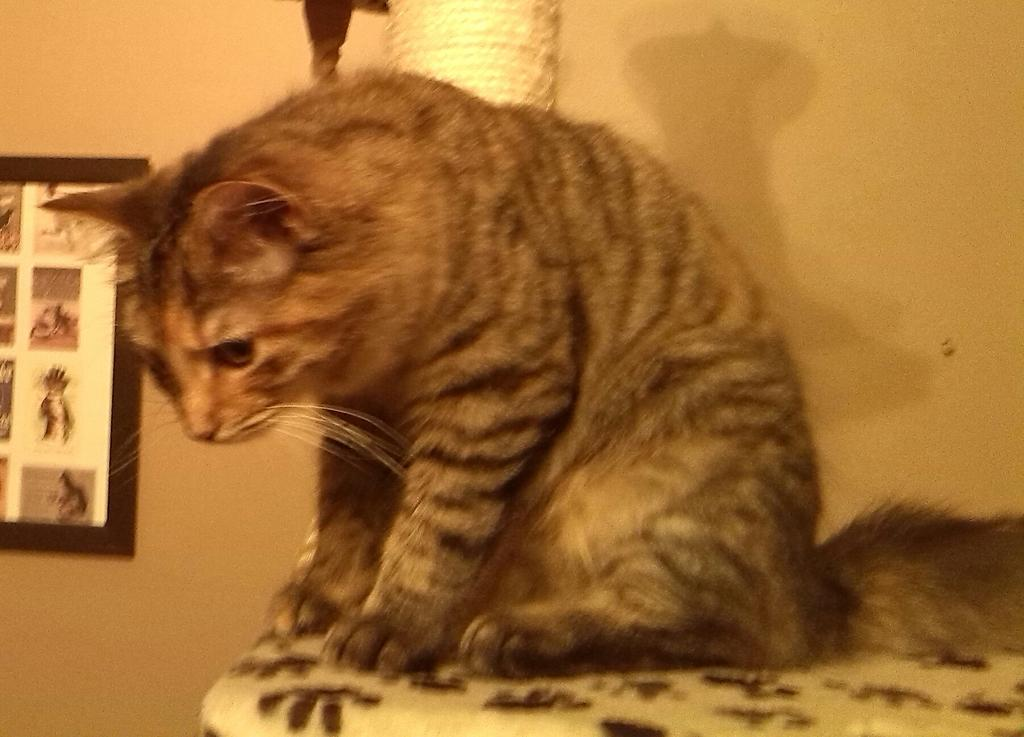What animal is present in the image? There is a cat in the image. Where is the cat located in the image? The cat is sitting on a platform. What can be seen in the background of the image? There is an object in the background of the image. What is on the wall in the background of the image? There is a frame on the wall in the background of the image. What type of fuel is the cat using to power its platform in the image? The image does not show the cat using any fuel to power its platform, nor does it mention anything about fuel. 